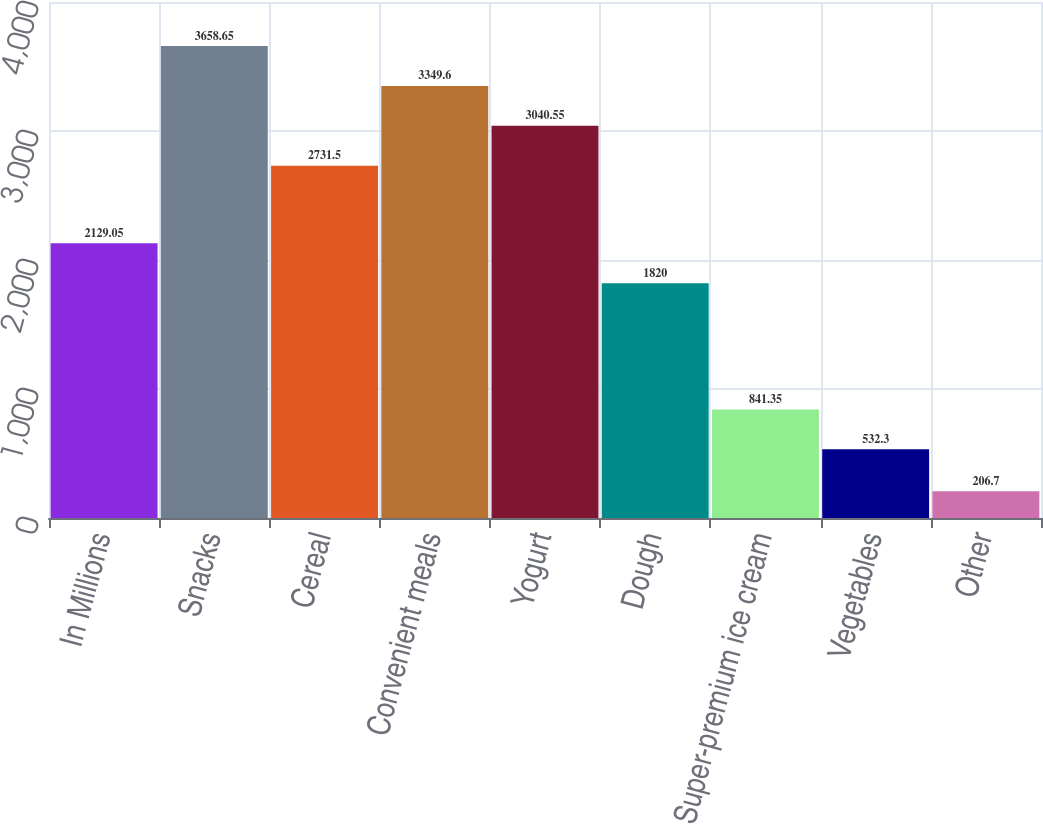Convert chart. <chart><loc_0><loc_0><loc_500><loc_500><bar_chart><fcel>In Millions<fcel>Snacks<fcel>Cereal<fcel>Convenient meals<fcel>Yogurt<fcel>Dough<fcel>Super-premium ice cream<fcel>Vegetables<fcel>Other<nl><fcel>2129.05<fcel>3658.65<fcel>2731.5<fcel>3349.6<fcel>3040.55<fcel>1820<fcel>841.35<fcel>532.3<fcel>206.7<nl></chart> 